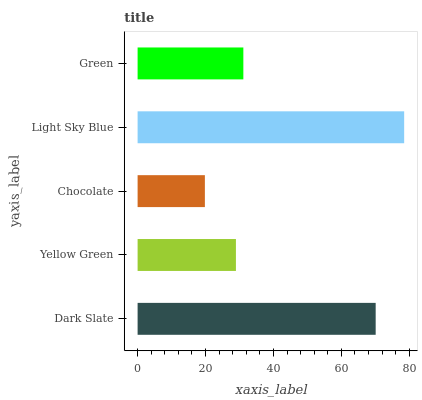Is Chocolate the minimum?
Answer yes or no. Yes. Is Light Sky Blue the maximum?
Answer yes or no. Yes. Is Yellow Green the minimum?
Answer yes or no. No. Is Yellow Green the maximum?
Answer yes or no. No. Is Dark Slate greater than Yellow Green?
Answer yes or no. Yes. Is Yellow Green less than Dark Slate?
Answer yes or no. Yes. Is Yellow Green greater than Dark Slate?
Answer yes or no. No. Is Dark Slate less than Yellow Green?
Answer yes or no. No. Is Green the high median?
Answer yes or no. Yes. Is Green the low median?
Answer yes or no. Yes. Is Yellow Green the high median?
Answer yes or no. No. Is Light Sky Blue the low median?
Answer yes or no. No. 